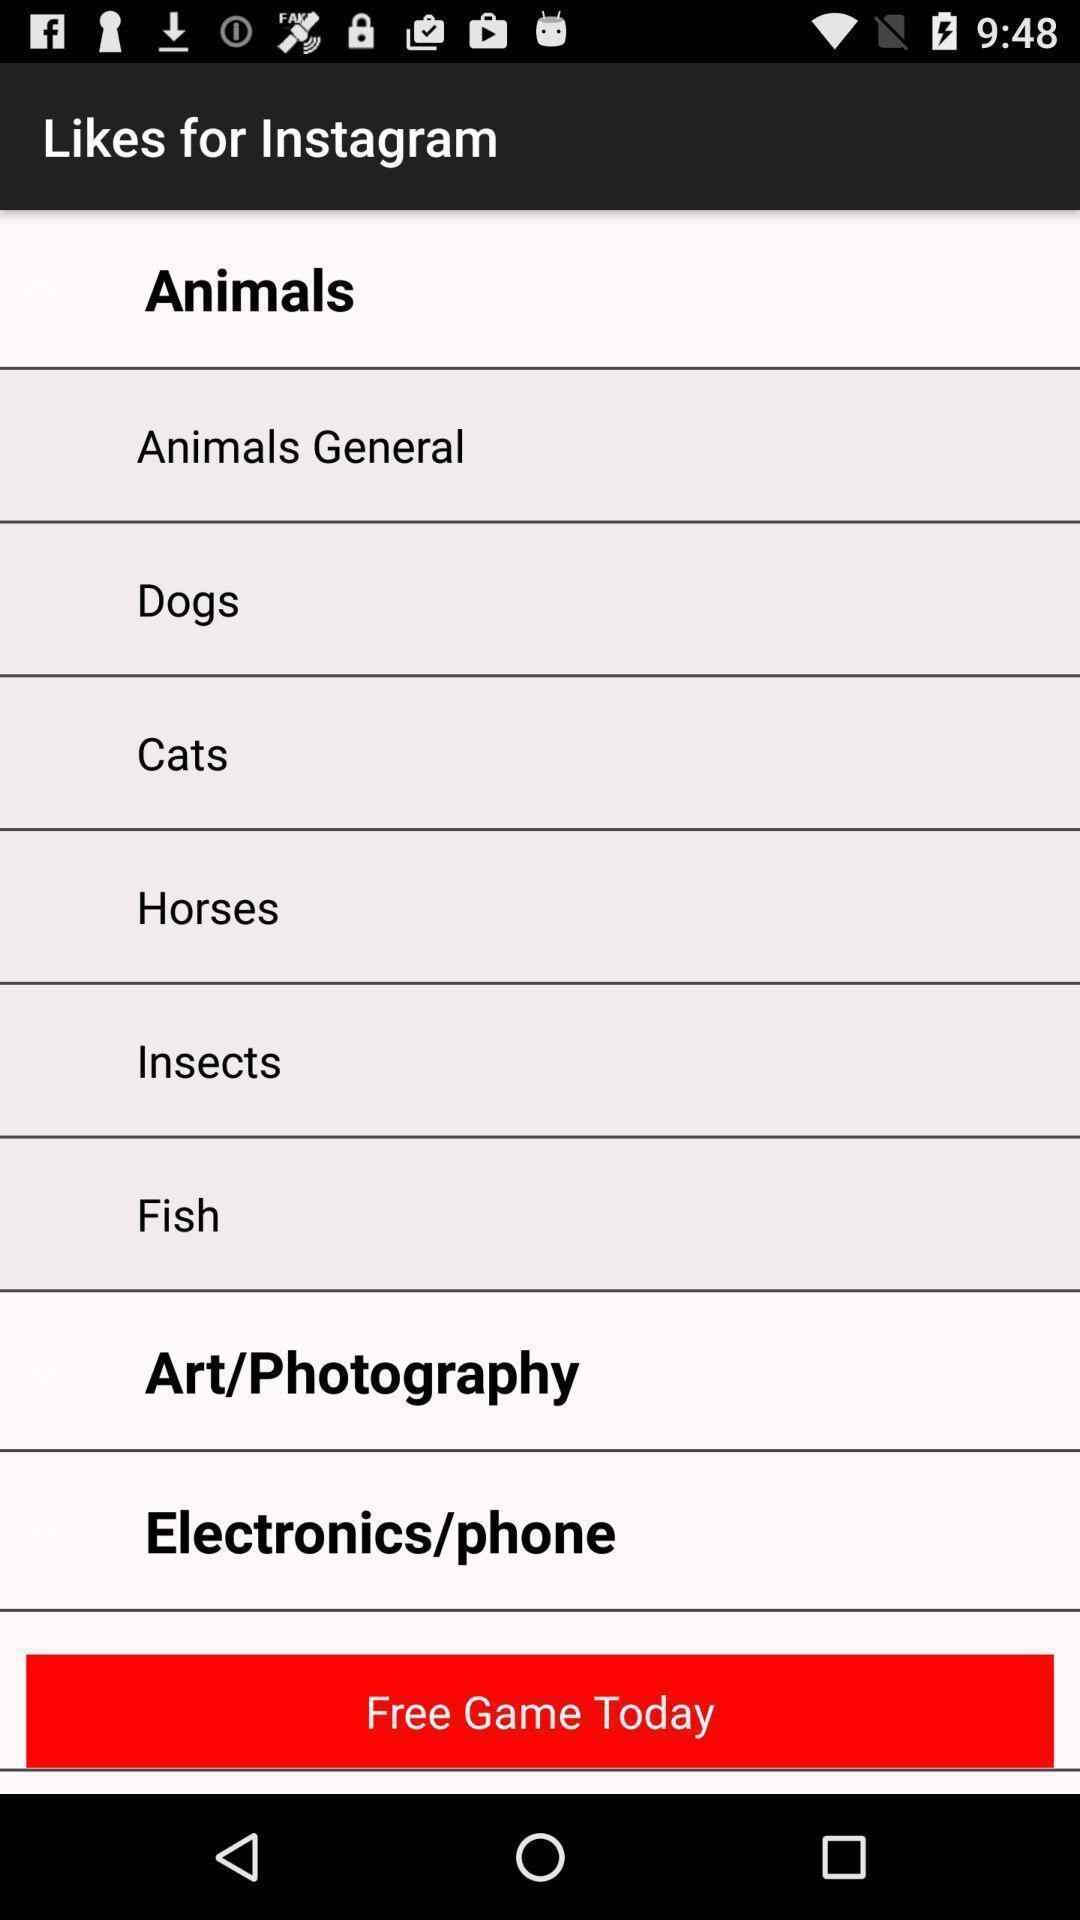Tell me what you see in this picture. Screen shows list of options in a social app. 